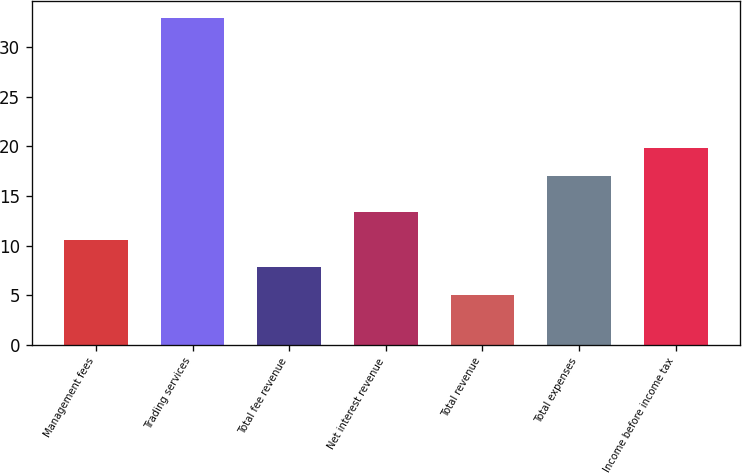Convert chart. <chart><loc_0><loc_0><loc_500><loc_500><bar_chart><fcel>Management fees<fcel>Trading services<fcel>Total fee revenue<fcel>Net interest revenue<fcel>Total revenue<fcel>Total expenses<fcel>Income before income tax<nl><fcel>10.6<fcel>33<fcel>7.8<fcel>13.4<fcel>5<fcel>17<fcel>19.8<nl></chart> 